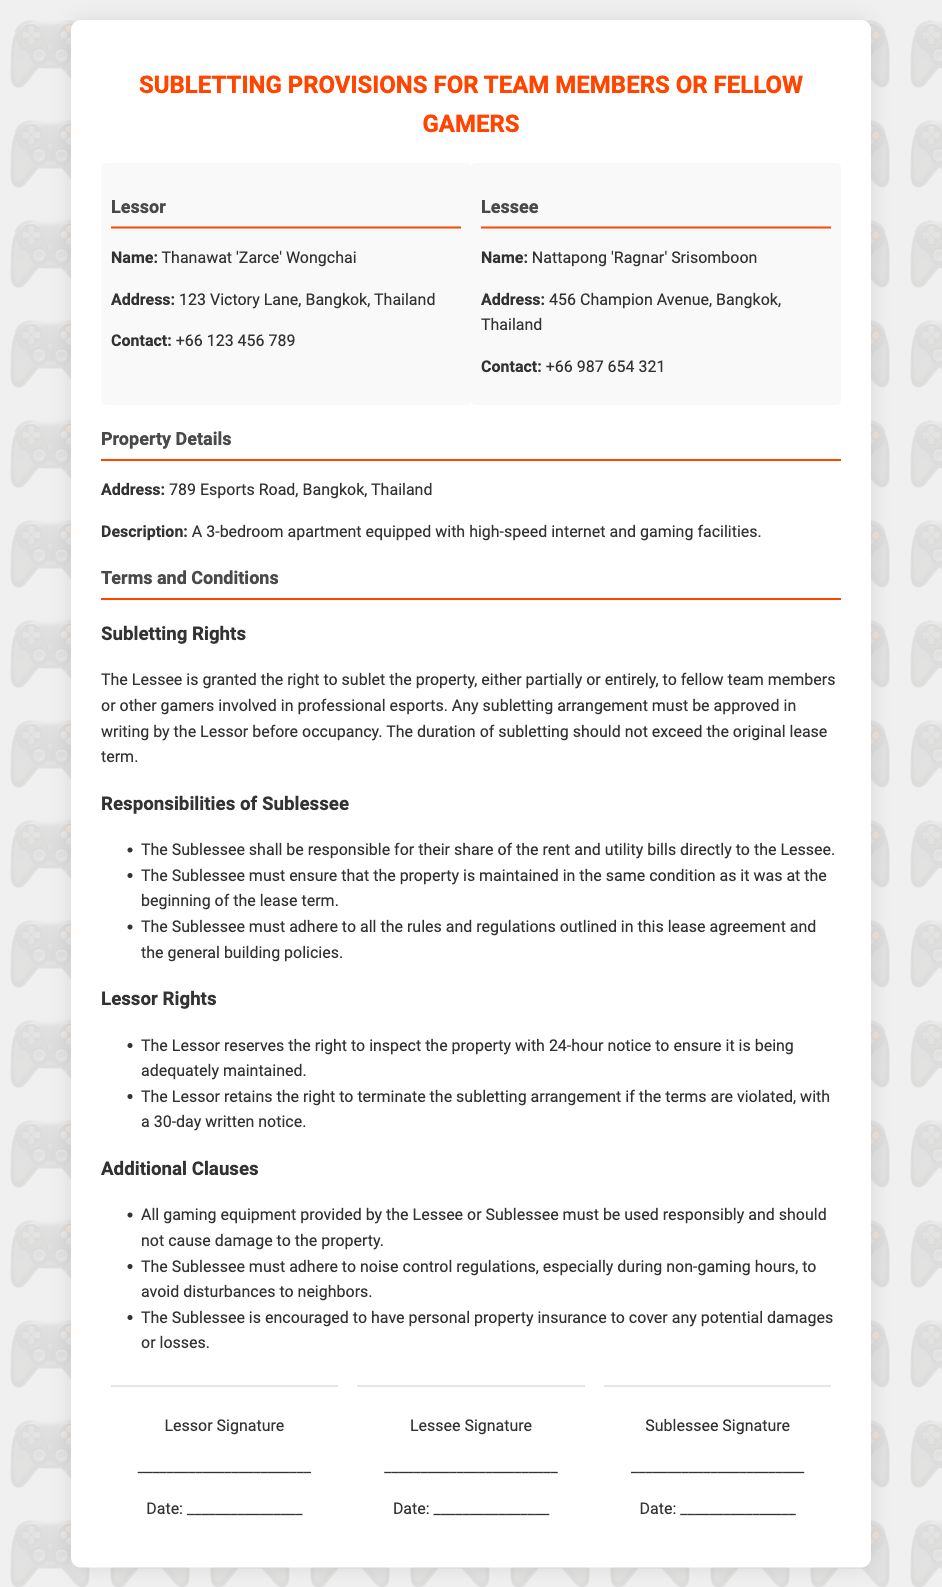What is the name of the Lessor? The Lessor's name is stated in the document as Thanawat 'Zarce' Wongchai.
Answer: Thanawat 'Zarce' Wongchai What is the address of the property? The property address is specified as 789 Esports Road, Bangkok, Thailand.
Answer: 789 Esports Road, Bangkok, Thailand What is the maximum duration for subletting? The document indicates that the duration of subletting should not exceed the original lease term.
Answer: Original lease term What must be provided before the subletting occupancy? The Lessee is required to obtain written approval from the Lessor before any subletting arrangement.
Answer: Written approval How much notice must the Lessor give before inspecting the property? The document specifies that the Lessor reserves the right to inspect with 24-hour notice.
Answer: 24-hour notice What responsibility does the Sublessee have regarding rent? The Sublessee must be responsible for their share of the rent and utility bills directly to the Lessee.
Answer: Share of rent and utility bills What is one of the additional clauses related to gaming equipment? The clause states that all gaming equipment must be used responsibly and should not cause damage to the property.
Answer: Used responsibly What is the Lessee's signature space labeled as? The section for the Lessee's signature is labeled "Lessee Signature."
Answer: Lessee Signature What happens if the subletting terms are violated? If violated, the Lessor retains the right to terminate the subletting arrangement with a 30-day written notice.
Answer: 30-day written notice 